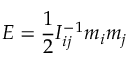Convert formula to latex. <formula><loc_0><loc_0><loc_500><loc_500>E = \frac { 1 } { 2 } I _ { i j } ^ { - 1 } m _ { i } m _ { j }</formula> 